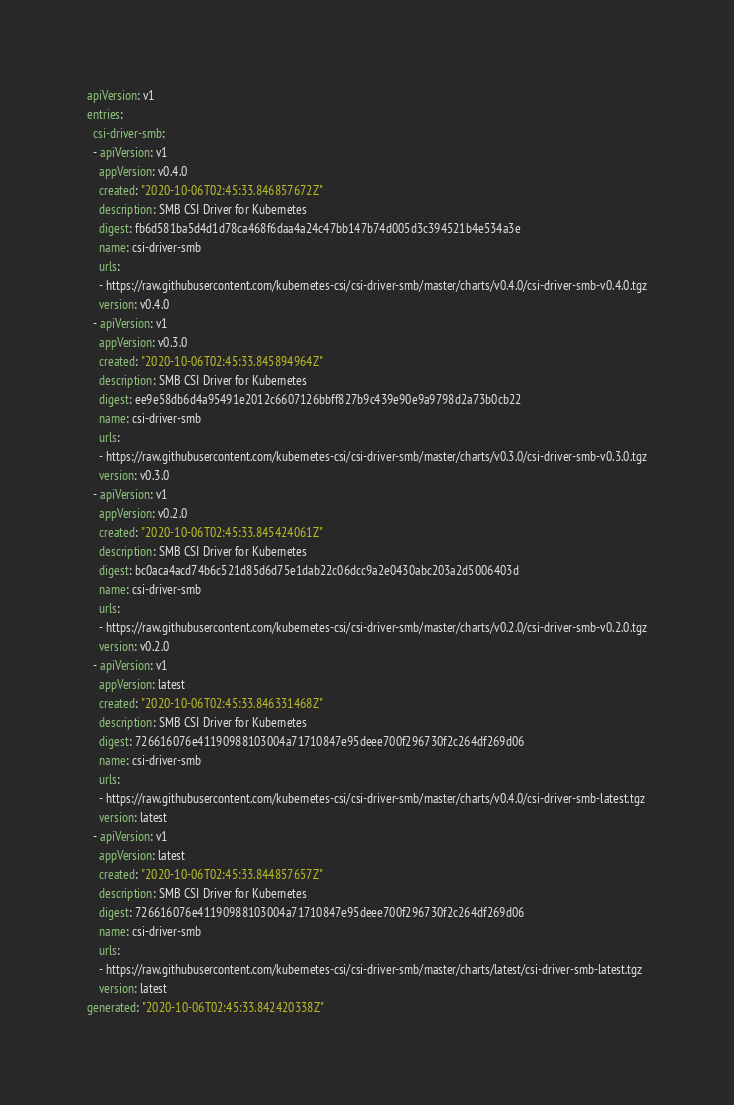Convert code to text. <code><loc_0><loc_0><loc_500><loc_500><_YAML_>apiVersion: v1
entries:
  csi-driver-smb:
  - apiVersion: v1
    appVersion: v0.4.0
    created: "2020-10-06T02:45:33.846857672Z"
    description: SMB CSI Driver for Kubernetes
    digest: fb6d581ba5d4d1d78ca468f6daa4a24c47bb147b74d005d3c394521b4e534a3e
    name: csi-driver-smb
    urls:
    - https://raw.githubusercontent.com/kubernetes-csi/csi-driver-smb/master/charts/v0.4.0/csi-driver-smb-v0.4.0.tgz
    version: v0.4.0
  - apiVersion: v1
    appVersion: v0.3.0
    created: "2020-10-06T02:45:33.845894964Z"
    description: SMB CSI Driver for Kubernetes
    digest: ee9e58db6d4a95491e2012c6607126bbff827b9c439e90e9a9798d2a73b0cb22
    name: csi-driver-smb
    urls:
    - https://raw.githubusercontent.com/kubernetes-csi/csi-driver-smb/master/charts/v0.3.0/csi-driver-smb-v0.3.0.tgz
    version: v0.3.0
  - apiVersion: v1
    appVersion: v0.2.0
    created: "2020-10-06T02:45:33.845424061Z"
    description: SMB CSI Driver for Kubernetes
    digest: bc0aca4acd74b6c521d85d6d75e1dab22c06dcc9a2e0430abc203a2d5006403d
    name: csi-driver-smb
    urls:
    - https://raw.githubusercontent.com/kubernetes-csi/csi-driver-smb/master/charts/v0.2.0/csi-driver-smb-v0.2.0.tgz
    version: v0.2.0
  - apiVersion: v1
    appVersion: latest
    created: "2020-10-06T02:45:33.846331468Z"
    description: SMB CSI Driver for Kubernetes
    digest: 726616076e41190988103004a71710847e95deee700f296730f2c264df269d06
    name: csi-driver-smb
    urls:
    - https://raw.githubusercontent.com/kubernetes-csi/csi-driver-smb/master/charts/v0.4.0/csi-driver-smb-latest.tgz
    version: latest
  - apiVersion: v1
    appVersion: latest
    created: "2020-10-06T02:45:33.844857657Z"
    description: SMB CSI Driver for Kubernetes
    digest: 726616076e41190988103004a71710847e95deee700f296730f2c264df269d06
    name: csi-driver-smb
    urls:
    - https://raw.githubusercontent.com/kubernetes-csi/csi-driver-smb/master/charts/latest/csi-driver-smb-latest.tgz
    version: latest
generated: "2020-10-06T02:45:33.842420338Z"
</code> 